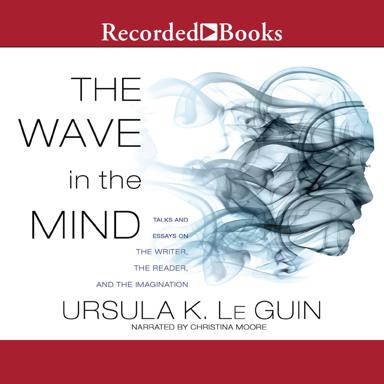How has this author impacted modern literature and the science fiction genre? Ursula K. Le Guin is a pivotal figure in modern literature, particularly in the science fiction and fantasy genres. Her works, including 'The Wave in the Mind', have challenged and expanded the boundaries of these genres by incorporating deep philosophical questions, anthropological themes, and progressive thoughts on societal structures and gender identity. 